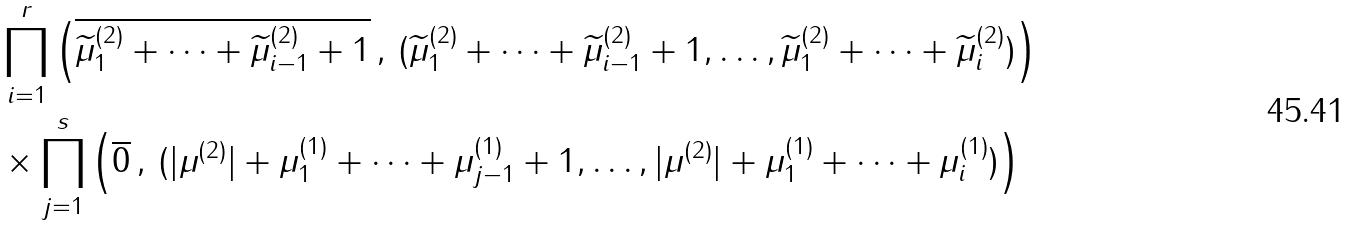Convert formula to latex. <formula><loc_0><loc_0><loc_500><loc_500>& \prod _ { i = 1 } ^ { r } \left ( \overline { \widetilde { \mu } ^ { ( 2 ) } _ { 1 } + \cdots + \widetilde { \mu } ^ { ( 2 ) } _ { i - 1 } + 1 } \, , \, ( \widetilde { \mu } ^ { ( 2 ) } _ { 1 } + \cdots + \widetilde { \mu } ^ { ( 2 ) } _ { i - 1 } + 1 , \dots , \widetilde { \mu } ^ { ( 2 ) } _ { 1 } + \cdots + \widetilde { \mu } ^ { ( 2 ) } _ { i } ) \right ) \\ & \times \prod _ { j = 1 } ^ { s } \left ( \overline { 0 } \, , \, ( | \mu ^ { ( 2 ) } | + \mu ^ { ( 1 ) } _ { 1 } + \cdots + \mu ^ { ( 1 ) } _ { j - 1 } + 1 , \dots , | \mu ^ { ( 2 ) } | + \mu ^ { ( 1 ) } _ { 1 } + \cdots + \mu ^ { ( 1 ) } _ { i } ) \right )</formula> 